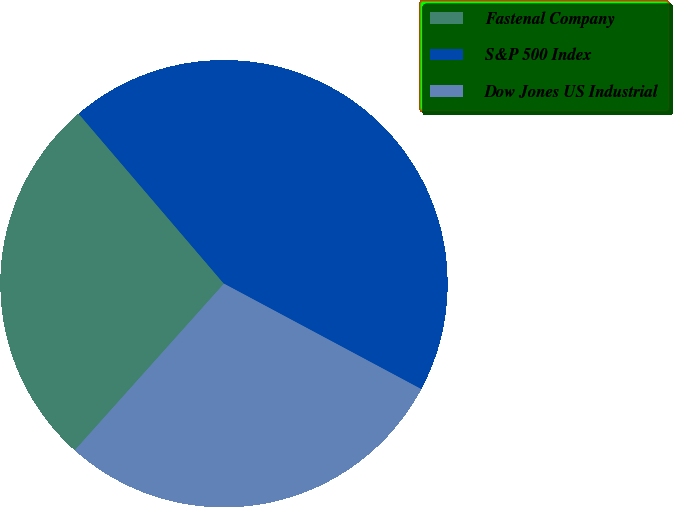Convert chart to OTSL. <chart><loc_0><loc_0><loc_500><loc_500><pie_chart><fcel>Fastenal Company<fcel>S&P 500 Index<fcel>Dow Jones US Industrial<nl><fcel>27.12%<fcel>44.07%<fcel>28.81%<nl></chart> 